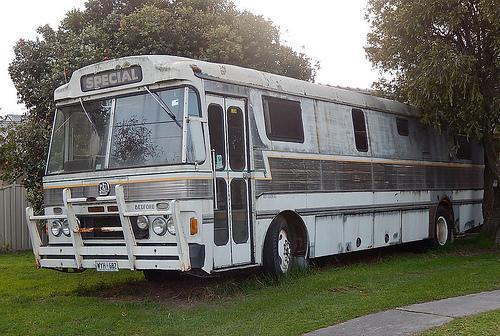How many tires does the bus have?
Give a very brief answer. 4. How many trees are there?
Give a very brief answer. 2. 